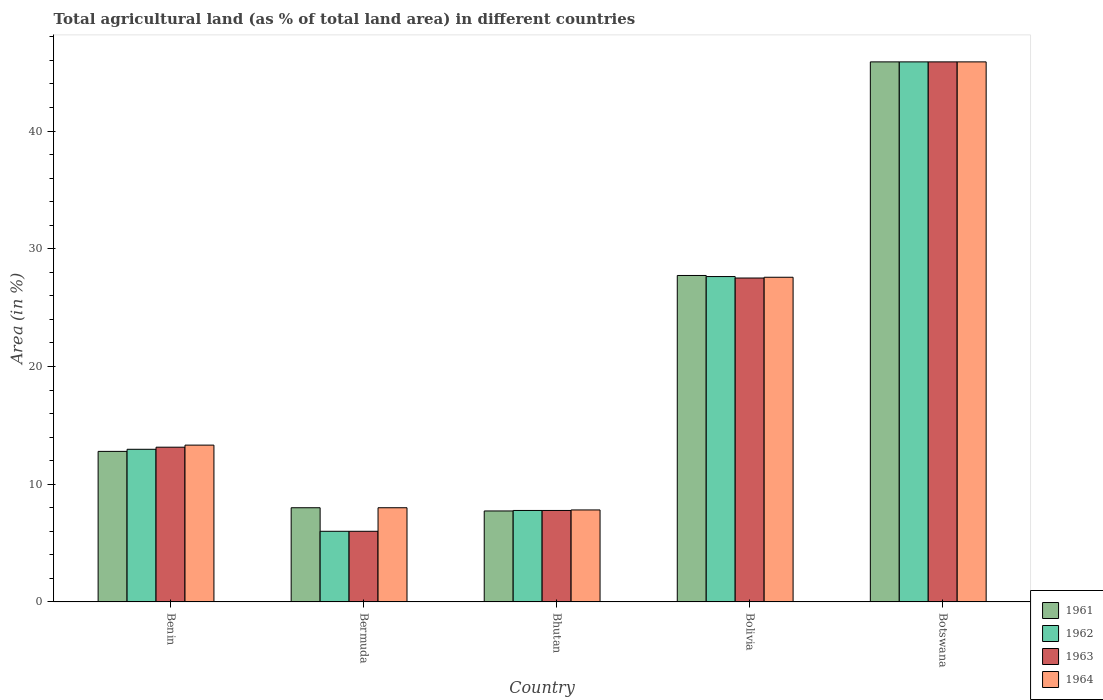How many groups of bars are there?
Provide a succinct answer. 5. How many bars are there on the 3rd tick from the left?
Your response must be concise. 4. What is the label of the 3rd group of bars from the left?
Offer a very short reply. Bhutan. In how many cases, is the number of bars for a given country not equal to the number of legend labels?
Your response must be concise. 0. What is the percentage of agricultural land in 1963 in Bolivia?
Provide a succinct answer. 27.52. Across all countries, what is the maximum percentage of agricultural land in 1961?
Your answer should be very brief. 45.88. Across all countries, what is the minimum percentage of agricultural land in 1963?
Offer a terse response. 6. In which country was the percentage of agricultural land in 1961 maximum?
Offer a very short reply. Botswana. In which country was the percentage of agricultural land in 1964 minimum?
Your answer should be very brief. Bhutan. What is the total percentage of agricultural land in 1963 in the graph?
Give a very brief answer. 100.3. What is the difference between the percentage of agricultural land in 1962 in Bermuda and that in Bhutan?
Your response must be concise. -1.77. What is the difference between the percentage of agricultural land in 1961 in Bolivia and the percentage of agricultural land in 1964 in Benin?
Your answer should be compact. 14.41. What is the average percentage of agricultural land in 1962 per country?
Offer a very short reply. 20.05. What is the difference between the percentage of agricultural land of/in 1961 and percentage of agricultural land of/in 1963 in Bhutan?
Provide a succinct answer. -0.04. What is the ratio of the percentage of agricultural land in 1962 in Benin to that in Bermuda?
Your response must be concise. 2.16. Is the percentage of agricultural land in 1964 in Bhutan less than that in Botswana?
Your answer should be very brief. Yes. What is the difference between the highest and the second highest percentage of agricultural land in 1962?
Offer a very short reply. 14.67. What is the difference between the highest and the lowest percentage of agricultural land in 1963?
Keep it short and to the point. 39.88. In how many countries, is the percentage of agricultural land in 1961 greater than the average percentage of agricultural land in 1961 taken over all countries?
Offer a very short reply. 2. What does the 1st bar from the left in Bolivia represents?
Make the answer very short. 1961. What does the 1st bar from the right in Benin represents?
Provide a succinct answer. 1964. Is it the case that in every country, the sum of the percentage of agricultural land in 1961 and percentage of agricultural land in 1964 is greater than the percentage of agricultural land in 1963?
Your answer should be very brief. Yes. Are all the bars in the graph horizontal?
Your answer should be compact. No. How many countries are there in the graph?
Provide a succinct answer. 5. What is the difference between two consecutive major ticks on the Y-axis?
Offer a terse response. 10. Are the values on the major ticks of Y-axis written in scientific E-notation?
Ensure brevity in your answer.  No. What is the title of the graph?
Make the answer very short. Total agricultural land (as % of total land area) in different countries. What is the label or title of the X-axis?
Offer a terse response. Country. What is the label or title of the Y-axis?
Ensure brevity in your answer.  Area (in %). What is the Area (in %) of 1961 in Benin?
Your answer should be very brief. 12.79. What is the Area (in %) in 1962 in Benin?
Provide a short and direct response. 12.97. What is the Area (in %) in 1963 in Benin?
Ensure brevity in your answer.  13.14. What is the Area (in %) of 1964 in Benin?
Make the answer very short. 13.32. What is the Area (in %) in 1963 in Bermuda?
Offer a terse response. 6. What is the Area (in %) of 1964 in Bermuda?
Ensure brevity in your answer.  8. What is the Area (in %) in 1961 in Bhutan?
Keep it short and to the point. 7.73. What is the Area (in %) of 1962 in Bhutan?
Provide a short and direct response. 7.77. What is the Area (in %) of 1963 in Bhutan?
Ensure brevity in your answer.  7.77. What is the Area (in %) of 1964 in Bhutan?
Offer a terse response. 7.81. What is the Area (in %) of 1961 in Bolivia?
Make the answer very short. 27.73. What is the Area (in %) in 1962 in Bolivia?
Your response must be concise. 27.64. What is the Area (in %) in 1963 in Bolivia?
Your answer should be very brief. 27.52. What is the Area (in %) in 1964 in Bolivia?
Keep it short and to the point. 27.58. What is the Area (in %) of 1961 in Botswana?
Provide a succinct answer. 45.88. What is the Area (in %) of 1962 in Botswana?
Ensure brevity in your answer.  45.88. What is the Area (in %) in 1963 in Botswana?
Your response must be concise. 45.88. What is the Area (in %) of 1964 in Botswana?
Your answer should be compact. 45.88. Across all countries, what is the maximum Area (in %) of 1961?
Ensure brevity in your answer.  45.88. Across all countries, what is the maximum Area (in %) of 1962?
Keep it short and to the point. 45.88. Across all countries, what is the maximum Area (in %) of 1963?
Provide a short and direct response. 45.88. Across all countries, what is the maximum Area (in %) in 1964?
Your response must be concise. 45.88. Across all countries, what is the minimum Area (in %) of 1961?
Keep it short and to the point. 7.73. Across all countries, what is the minimum Area (in %) of 1963?
Offer a very short reply. 6. Across all countries, what is the minimum Area (in %) in 1964?
Your answer should be compact. 7.81. What is the total Area (in %) of 1961 in the graph?
Your response must be concise. 102.12. What is the total Area (in %) in 1962 in the graph?
Give a very brief answer. 100.25. What is the total Area (in %) in 1963 in the graph?
Keep it short and to the point. 100.3. What is the total Area (in %) of 1964 in the graph?
Your answer should be compact. 102.59. What is the difference between the Area (in %) in 1961 in Benin and that in Bermuda?
Provide a succinct answer. 4.79. What is the difference between the Area (in %) of 1962 in Benin and that in Bermuda?
Provide a succinct answer. 6.97. What is the difference between the Area (in %) in 1963 in Benin and that in Bermuda?
Ensure brevity in your answer.  7.14. What is the difference between the Area (in %) of 1964 in Benin and that in Bermuda?
Offer a terse response. 5.32. What is the difference between the Area (in %) of 1961 in Benin and that in Bhutan?
Your answer should be very brief. 5.06. What is the difference between the Area (in %) in 1962 in Benin and that in Bhutan?
Provide a short and direct response. 5.2. What is the difference between the Area (in %) in 1963 in Benin and that in Bhutan?
Your response must be concise. 5.37. What is the difference between the Area (in %) in 1964 in Benin and that in Bhutan?
Keep it short and to the point. 5.51. What is the difference between the Area (in %) of 1961 in Benin and that in Bolivia?
Give a very brief answer. -14.94. What is the difference between the Area (in %) of 1962 in Benin and that in Bolivia?
Provide a short and direct response. -14.67. What is the difference between the Area (in %) of 1963 in Benin and that in Bolivia?
Ensure brevity in your answer.  -14.37. What is the difference between the Area (in %) in 1964 in Benin and that in Bolivia?
Provide a succinct answer. -14.26. What is the difference between the Area (in %) of 1961 in Benin and that in Botswana?
Ensure brevity in your answer.  -33.09. What is the difference between the Area (in %) of 1962 in Benin and that in Botswana?
Give a very brief answer. -32.91. What is the difference between the Area (in %) of 1963 in Benin and that in Botswana?
Provide a short and direct response. -32.73. What is the difference between the Area (in %) of 1964 in Benin and that in Botswana?
Keep it short and to the point. -32.56. What is the difference between the Area (in %) of 1961 in Bermuda and that in Bhutan?
Provide a short and direct response. 0.27. What is the difference between the Area (in %) of 1962 in Bermuda and that in Bhutan?
Offer a very short reply. -1.77. What is the difference between the Area (in %) in 1963 in Bermuda and that in Bhutan?
Make the answer very short. -1.77. What is the difference between the Area (in %) in 1964 in Bermuda and that in Bhutan?
Provide a short and direct response. 0.19. What is the difference between the Area (in %) in 1961 in Bermuda and that in Bolivia?
Make the answer very short. -19.73. What is the difference between the Area (in %) in 1962 in Bermuda and that in Bolivia?
Make the answer very short. -21.64. What is the difference between the Area (in %) in 1963 in Bermuda and that in Bolivia?
Give a very brief answer. -21.52. What is the difference between the Area (in %) in 1964 in Bermuda and that in Bolivia?
Keep it short and to the point. -19.58. What is the difference between the Area (in %) of 1961 in Bermuda and that in Botswana?
Provide a short and direct response. -37.88. What is the difference between the Area (in %) in 1962 in Bermuda and that in Botswana?
Your answer should be very brief. -39.88. What is the difference between the Area (in %) of 1963 in Bermuda and that in Botswana?
Provide a short and direct response. -39.88. What is the difference between the Area (in %) in 1964 in Bermuda and that in Botswana?
Ensure brevity in your answer.  -37.88. What is the difference between the Area (in %) in 1961 in Bhutan and that in Bolivia?
Provide a succinct answer. -20.01. What is the difference between the Area (in %) of 1962 in Bhutan and that in Bolivia?
Give a very brief answer. -19.87. What is the difference between the Area (in %) of 1963 in Bhutan and that in Bolivia?
Your answer should be compact. -19.75. What is the difference between the Area (in %) in 1964 in Bhutan and that in Bolivia?
Provide a short and direct response. -19.77. What is the difference between the Area (in %) in 1961 in Bhutan and that in Botswana?
Make the answer very short. -38.15. What is the difference between the Area (in %) in 1962 in Bhutan and that in Botswana?
Offer a very short reply. -38.11. What is the difference between the Area (in %) of 1963 in Bhutan and that in Botswana?
Make the answer very short. -38.11. What is the difference between the Area (in %) in 1964 in Bhutan and that in Botswana?
Make the answer very short. -38.07. What is the difference between the Area (in %) in 1961 in Bolivia and that in Botswana?
Give a very brief answer. -18.15. What is the difference between the Area (in %) of 1962 in Bolivia and that in Botswana?
Give a very brief answer. -18.24. What is the difference between the Area (in %) of 1963 in Bolivia and that in Botswana?
Make the answer very short. -18.36. What is the difference between the Area (in %) in 1964 in Bolivia and that in Botswana?
Keep it short and to the point. -18.3. What is the difference between the Area (in %) of 1961 in Benin and the Area (in %) of 1962 in Bermuda?
Your response must be concise. 6.79. What is the difference between the Area (in %) in 1961 in Benin and the Area (in %) in 1963 in Bermuda?
Ensure brevity in your answer.  6.79. What is the difference between the Area (in %) in 1961 in Benin and the Area (in %) in 1964 in Bermuda?
Your answer should be compact. 4.79. What is the difference between the Area (in %) in 1962 in Benin and the Area (in %) in 1963 in Bermuda?
Your answer should be very brief. 6.97. What is the difference between the Area (in %) of 1962 in Benin and the Area (in %) of 1964 in Bermuda?
Provide a succinct answer. 4.97. What is the difference between the Area (in %) in 1963 in Benin and the Area (in %) in 1964 in Bermuda?
Your response must be concise. 5.14. What is the difference between the Area (in %) of 1961 in Benin and the Area (in %) of 1962 in Bhutan?
Ensure brevity in your answer.  5.02. What is the difference between the Area (in %) of 1961 in Benin and the Area (in %) of 1963 in Bhutan?
Provide a succinct answer. 5.02. What is the difference between the Area (in %) in 1961 in Benin and the Area (in %) in 1964 in Bhutan?
Your answer should be very brief. 4.98. What is the difference between the Area (in %) of 1962 in Benin and the Area (in %) of 1963 in Bhutan?
Your answer should be very brief. 5.2. What is the difference between the Area (in %) of 1962 in Benin and the Area (in %) of 1964 in Bhutan?
Ensure brevity in your answer.  5.15. What is the difference between the Area (in %) of 1963 in Benin and the Area (in %) of 1964 in Bhutan?
Provide a succinct answer. 5.33. What is the difference between the Area (in %) in 1961 in Benin and the Area (in %) in 1962 in Bolivia?
Offer a terse response. -14.85. What is the difference between the Area (in %) in 1961 in Benin and the Area (in %) in 1963 in Bolivia?
Offer a terse response. -14.73. What is the difference between the Area (in %) of 1961 in Benin and the Area (in %) of 1964 in Bolivia?
Your answer should be very brief. -14.79. What is the difference between the Area (in %) in 1962 in Benin and the Area (in %) in 1963 in Bolivia?
Provide a short and direct response. -14.55. What is the difference between the Area (in %) in 1962 in Benin and the Area (in %) in 1964 in Bolivia?
Make the answer very short. -14.62. What is the difference between the Area (in %) in 1963 in Benin and the Area (in %) in 1964 in Bolivia?
Keep it short and to the point. -14.44. What is the difference between the Area (in %) of 1961 in Benin and the Area (in %) of 1962 in Botswana?
Provide a short and direct response. -33.09. What is the difference between the Area (in %) of 1961 in Benin and the Area (in %) of 1963 in Botswana?
Give a very brief answer. -33.09. What is the difference between the Area (in %) in 1961 in Benin and the Area (in %) in 1964 in Botswana?
Keep it short and to the point. -33.09. What is the difference between the Area (in %) in 1962 in Benin and the Area (in %) in 1963 in Botswana?
Ensure brevity in your answer.  -32.91. What is the difference between the Area (in %) of 1962 in Benin and the Area (in %) of 1964 in Botswana?
Offer a very short reply. -32.91. What is the difference between the Area (in %) of 1963 in Benin and the Area (in %) of 1964 in Botswana?
Your response must be concise. -32.73. What is the difference between the Area (in %) in 1961 in Bermuda and the Area (in %) in 1962 in Bhutan?
Ensure brevity in your answer.  0.23. What is the difference between the Area (in %) in 1961 in Bermuda and the Area (in %) in 1963 in Bhutan?
Give a very brief answer. 0.23. What is the difference between the Area (in %) in 1961 in Bermuda and the Area (in %) in 1964 in Bhutan?
Make the answer very short. 0.19. What is the difference between the Area (in %) in 1962 in Bermuda and the Area (in %) in 1963 in Bhutan?
Provide a short and direct response. -1.77. What is the difference between the Area (in %) of 1962 in Bermuda and the Area (in %) of 1964 in Bhutan?
Offer a very short reply. -1.81. What is the difference between the Area (in %) in 1963 in Bermuda and the Area (in %) in 1964 in Bhutan?
Your response must be concise. -1.81. What is the difference between the Area (in %) in 1961 in Bermuda and the Area (in %) in 1962 in Bolivia?
Keep it short and to the point. -19.64. What is the difference between the Area (in %) of 1961 in Bermuda and the Area (in %) of 1963 in Bolivia?
Give a very brief answer. -19.52. What is the difference between the Area (in %) in 1961 in Bermuda and the Area (in %) in 1964 in Bolivia?
Offer a very short reply. -19.58. What is the difference between the Area (in %) in 1962 in Bermuda and the Area (in %) in 1963 in Bolivia?
Your answer should be very brief. -21.52. What is the difference between the Area (in %) of 1962 in Bermuda and the Area (in %) of 1964 in Bolivia?
Offer a terse response. -21.58. What is the difference between the Area (in %) in 1963 in Bermuda and the Area (in %) in 1964 in Bolivia?
Offer a very short reply. -21.58. What is the difference between the Area (in %) in 1961 in Bermuda and the Area (in %) in 1962 in Botswana?
Give a very brief answer. -37.88. What is the difference between the Area (in %) in 1961 in Bermuda and the Area (in %) in 1963 in Botswana?
Offer a terse response. -37.88. What is the difference between the Area (in %) of 1961 in Bermuda and the Area (in %) of 1964 in Botswana?
Keep it short and to the point. -37.88. What is the difference between the Area (in %) in 1962 in Bermuda and the Area (in %) in 1963 in Botswana?
Offer a terse response. -39.88. What is the difference between the Area (in %) of 1962 in Bermuda and the Area (in %) of 1964 in Botswana?
Provide a short and direct response. -39.88. What is the difference between the Area (in %) of 1963 in Bermuda and the Area (in %) of 1964 in Botswana?
Offer a terse response. -39.88. What is the difference between the Area (in %) of 1961 in Bhutan and the Area (in %) of 1962 in Bolivia?
Keep it short and to the point. -19.91. What is the difference between the Area (in %) of 1961 in Bhutan and the Area (in %) of 1963 in Bolivia?
Offer a terse response. -19.79. What is the difference between the Area (in %) of 1961 in Bhutan and the Area (in %) of 1964 in Bolivia?
Provide a short and direct response. -19.85. What is the difference between the Area (in %) in 1962 in Bhutan and the Area (in %) in 1963 in Bolivia?
Your answer should be very brief. -19.75. What is the difference between the Area (in %) in 1962 in Bhutan and the Area (in %) in 1964 in Bolivia?
Keep it short and to the point. -19.81. What is the difference between the Area (in %) in 1963 in Bhutan and the Area (in %) in 1964 in Bolivia?
Ensure brevity in your answer.  -19.81. What is the difference between the Area (in %) in 1961 in Bhutan and the Area (in %) in 1962 in Botswana?
Your response must be concise. -38.15. What is the difference between the Area (in %) in 1961 in Bhutan and the Area (in %) in 1963 in Botswana?
Make the answer very short. -38.15. What is the difference between the Area (in %) in 1961 in Bhutan and the Area (in %) in 1964 in Botswana?
Provide a succinct answer. -38.15. What is the difference between the Area (in %) of 1962 in Bhutan and the Area (in %) of 1963 in Botswana?
Offer a terse response. -38.11. What is the difference between the Area (in %) in 1962 in Bhutan and the Area (in %) in 1964 in Botswana?
Offer a terse response. -38.11. What is the difference between the Area (in %) of 1963 in Bhutan and the Area (in %) of 1964 in Botswana?
Make the answer very short. -38.11. What is the difference between the Area (in %) of 1961 in Bolivia and the Area (in %) of 1962 in Botswana?
Offer a terse response. -18.15. What is the difference between the Area (in %) in 1961 in Bolivia and the Area (in %) in 1963 in Botswana?
Make the answer very short. -18.15. What is the difference between the Area (in %) of 1961 in Bolivia and the Area (in %) of 1964 in Botswana?
Offer a terse response. -18.15. What is the difference between the Area (in %) of 1962 in Bolivia and the Area (in %) of 1963 in Botswana?
Your response must be concise. -18.24. What is the difference between the Area (in %) in 1962 in Bolivia and the Area (in %) in 1964 in Botswana?
Your answer should be compact. -18.24. What is the difference between the Area (in %) in 1963 in Bolivia and the Area (in %) in 1964 in Botswana?
Offer a terse response. -18.36. What is the average Area (in %) in 1961 per country?
Your response must be concise. 20.42. What is the average Area (in %) in 1962 per country?
Your answer should be compact. 20.05. What is the average Area (in %) in 1963 per country?
Provide a short and direct response. 20.06. What is the average Area (in %) in 1964 per country?
Your response must be concise. 20.52. What is the difference between the Area (in %) of 1961 and Area (in %) of 1962 in Benin?
Your answer should be compact. -0.18. What is the difference between the Area (in %) of 1961 and Area (in %) of 1963 in Benin?
Provide a short and direct response. -0.35. What is the difference between the Area (in %) in 1961 and Area (in %) in 1964 in Benin?
Provide a succinct answer. -0.53. What is the difference between the Area (in %) in 1962 and Area (in %) in 1963 in Benin?
Offer a terse response. -0.18. What is the difference between the Area (in %) of 1962 and Area (in %) of 1964 in Benin?
Give a very brief answer. -0.35. What is the difference between the Area (in %) in 1963 and Area (in %) in 1964 in Benin?
Ensure brevity in your answer.  -0.18. What is the difference between the Area (in %) in 1961 and Area (in %) in 1962 in Bermuda?
Your response must be concise. 2. What is the difference between the Area (in %) of 1961 and Area (in %) of 1963 in Bermuda?
Provide a succinct answer. 2. What is the difference between the Area (in %) in 1961 and Area (in %) in 1964 in Bermuda?
Provide a short and direct response. 0. What is the difference between the Area (in %) in 1962 and Area (in %) in 1963 in Bermuda?
Your response must be concise. 0. What is the difference between the Area (in %) of 1961 and Area (in %) of 1962 in Bhutan?
Your response must be concise. -0.04. What is the difference between the Area (in %) of 1961 and Area (in %) of 1963 in Bhutan?
Provide a succinct answer. -0.04. What is the difference between the Area (in %) of 1961 and Area (in %) of 1964 in Bhutan?
Offer a very short reply. -0.09. What is the difference between the Area (in %) of 1962 and Area (in %) of 1964 in Bhutan?
Your response must be concise. -0.04. What is the difference between the Area (in %) of 1963 and Area (in %) of 1964 in Bhutan?
Offer a terse response. -0.04. What is the difference between the Area (in %) in 1961 and Area (in %) in 1962 in Bolivia?
Provide a short and direct response. 0.09. What is the difference between the Area (in %) in 1961 and Area (in %) in 1963 in Bolivia?
Provide a short and direct response. 0.22. What is the difference between the Area (in %) in 1961 and Area (in %) in 1964 in Bolivia?
Keep it short and to the point. 0.15. What is the difference between the Area (in %) of 1962 and Area (in %) of 1963 in Bolivia?
Keep it short and to the point. 0.12. What is the difference between the Area (in %) of 1962 and Area (in %) of 1964 in Bolivia?
Your answer should be very brief. 0.06. What is the difference between the Area (in %) in 1963 and Area (in %) in 1964 in Bolivia?
Keep it short and to the point. -0.07. What is the difference between the Area (in %) in 1962 and Area (in %) in 1963 in Botswana?
Make the answer very short. 0. What is the difference between the Area (in %) in 1962 and Area (in %) in 1964 in Botswana?
Your response must be concise. 0. What is the difference between the Area (in %) of 1963 and Area (in %) of 1964 in Botswana?
Offer a terse response. 0. What is the ratio of the Area (in %) of 1961 in Benin to that in Bermuda?
Your response must be concise. 1.6. What is the ratio of the Area (in %) in 1962 in Benin to that in Bermuda?
Your answer should be very brief. 2.16. What is the ratio of the Area (in %) of 1963 in Benin to that in Bermuda?
Provide a succinct answer. 2.19. What is the ratio of the Area (in %) of 1964 in Benin to that in Bermuda?
Make the answer very short. 1.67. What is the ratio of the Area (in %) of 1961 in Benin to that in Bhutan?
Your answer should be compact. 1.66. What is the ratio of the Area (in %) in 1962 in Benin to that in Bhutan?
Offer a very short reply. 1.67. What is the ratio of the Area (in %) in 1963 in Benin to that in Bhutan?
Your answer should be compact. 1.69. What is the ratio of the Area (in %) in 1964 in Benin to that in Bhutan?
Provide a succinct answer. 1.71. What is the ratio of the Area (in %) of 1961 in Benin to that in Bolivia?
Your answer should be compact. 0.46. What is the ratio of the Area (in %) of 1962 in Benin to that in Bolivia?
Ensure brevity in your answer.  0.47. What is the ratio of the Area (in %) of 1963 in Benin to that in Bolivia?
Your answer should be compact. 0.48. What is the ratio of the Area (in %) of 1964 in Benin to that in Bolivia?
Provide a succinct answer. 0.48. What is the ratio of the Area (in %) of 1961 in Benin to that in Botswana?
Keep it short and to the point. 0.28. What is the ratio of the Area (in %) of 1962 in Benin to that in Botswana?
Offer a very short reply. 0.28. What is the ratio of the Area (in %) of 1963 in Benin to that in Botswana?
Keep it short and to the point. 0.29. What is the ratio of the Area (in %) of 1964 in Benin to that in Botswana?
Provide a short and direct response. 0.29. What is the ratio of the Area (in %) in 1961 in Bermuda to that in Bhutan?
Your response must be concise. 1.04. What is the ratio of the Area (in %) in 1962 in Bermuda to that in Bhutan?
Offer a very short reply. 0.77. What is the ratio of the Area (in %) in 1963 in Bermuda to that in Bhutan?
Your answer should be compact. 0.77. What is the ratio of the Area (in %) of 1964 in Bermuda to that in Bhutan?
Provide a short and direct response. 1.02. What is the ratio of the Area (in %) in 1961 in Bermuda to that in Bolivia?
Offer a terse response. 0.29. What is the ratio of the Area (in %) in 1962 in Bermuda to that in Bolivia?
Offer a terse response. 0.22. What is the ratio of the Area (in %) of 1963 in Bermuda to that in Bolivia?
Give a very brief answer. 0.22. What is the ratio of the Area (in %) in 1964 in Bermuda to that in Bolivia?
Provide a short and direct response. 0.29. What is the ratio of the Area (in %) of 1961 in Bermuda to that in Botswana?
Ensure brevity in your answer.  0.17. What is the ratio of the Area (in %) in 1962 in Bermuda to that in Botswana?
Your answer should be compact. 0.13. What is the ratio of the Area (in %) in 1963 in Bermuda to that in Botswana?
Keep it short and to the point. 0.13. What is the ratio of the Area (in %) of 1964 in Bermuda to that in Botswana?
Provide a short and direct response. 0.17. What is the ratio of the Area (in %) in 1961 in Bhutan to that in Bolivia?
Give a very brief answer. 0.28. What is the ratio of the Area (in %) of 1962 in Bhutan to that in Bolivia?
Your answer should be compact. 0.28. What is the ratio of the Area (in %) of 1963 in Bhutan to that in Bolivia?
Keep it short and to the point. 0.28. What is the ratio of the Area (in %) of 1964 in Bhutan to that in Bolivia?
Ensure brevity in your answer.  0.28. What is the ratio of the Area (in %) in 1961 in Bhutan to that in Botswana?
Keep it short and to the point. 0.17. What is the ratio of the Area (in %) in 1962 in Bhutan to that in Botswana?
Offer a terse response. 0.17. What is the ratio of the Area (in %) of 1963 in Bhutan to that in Botswana?
Keep it short and to the point. 0.17. What is the ratio of the Area (in %) of 1964 in Bhutan to that in Botswana?
Keep it short and to the point. 0.17. What is the ratio of the Area (in %) in 1961 in Bolivia to that in Botswana?
Provide a succinct answer. 0.6. What is the ratio of the Area (in %) in 1962 in Bolivia to that in Botswana?
Provide a short and direct response. 0.6. What is the ratio of the Area (in %) of 1963 in Bolivia to that in Botswana?
Your answer should be very brief. 0.6. What is the ratio of the Area (in %) in 1964 in Bolivia to that in Botswana?
Provide a short and direct response. 0.6. What is the difference between the highest and the second highest Area (in %) of 1961?
Your answer should be compact. 18.15. What is the difference between the highest and the second highest Area (in %) in 1962?
Ensure brevity in your answer.  18.24. What is the difference between the highest and the second highest Area (in %) of 1963?
Ensure brevity in your answer.  18.36. What is the difference between the highest and the second highest Area (in %) of 1964?
Offer a terse response. 18.3. What is the difference between the highest and the lowest Area (in %) in 1961?
Your answer should be compact. 38.15. What is the difference between the highest and the lowest Area (in %) of 1962?
Give a very brief answer. 39.88. What is the difference between the highest and the lowest Area (in %) of 1963?
Ensure brevity in your answer.  39.88. What is the difference between the highest and the lowest Area (in %) of 1964?
Offer a very short reply. 38.07. 